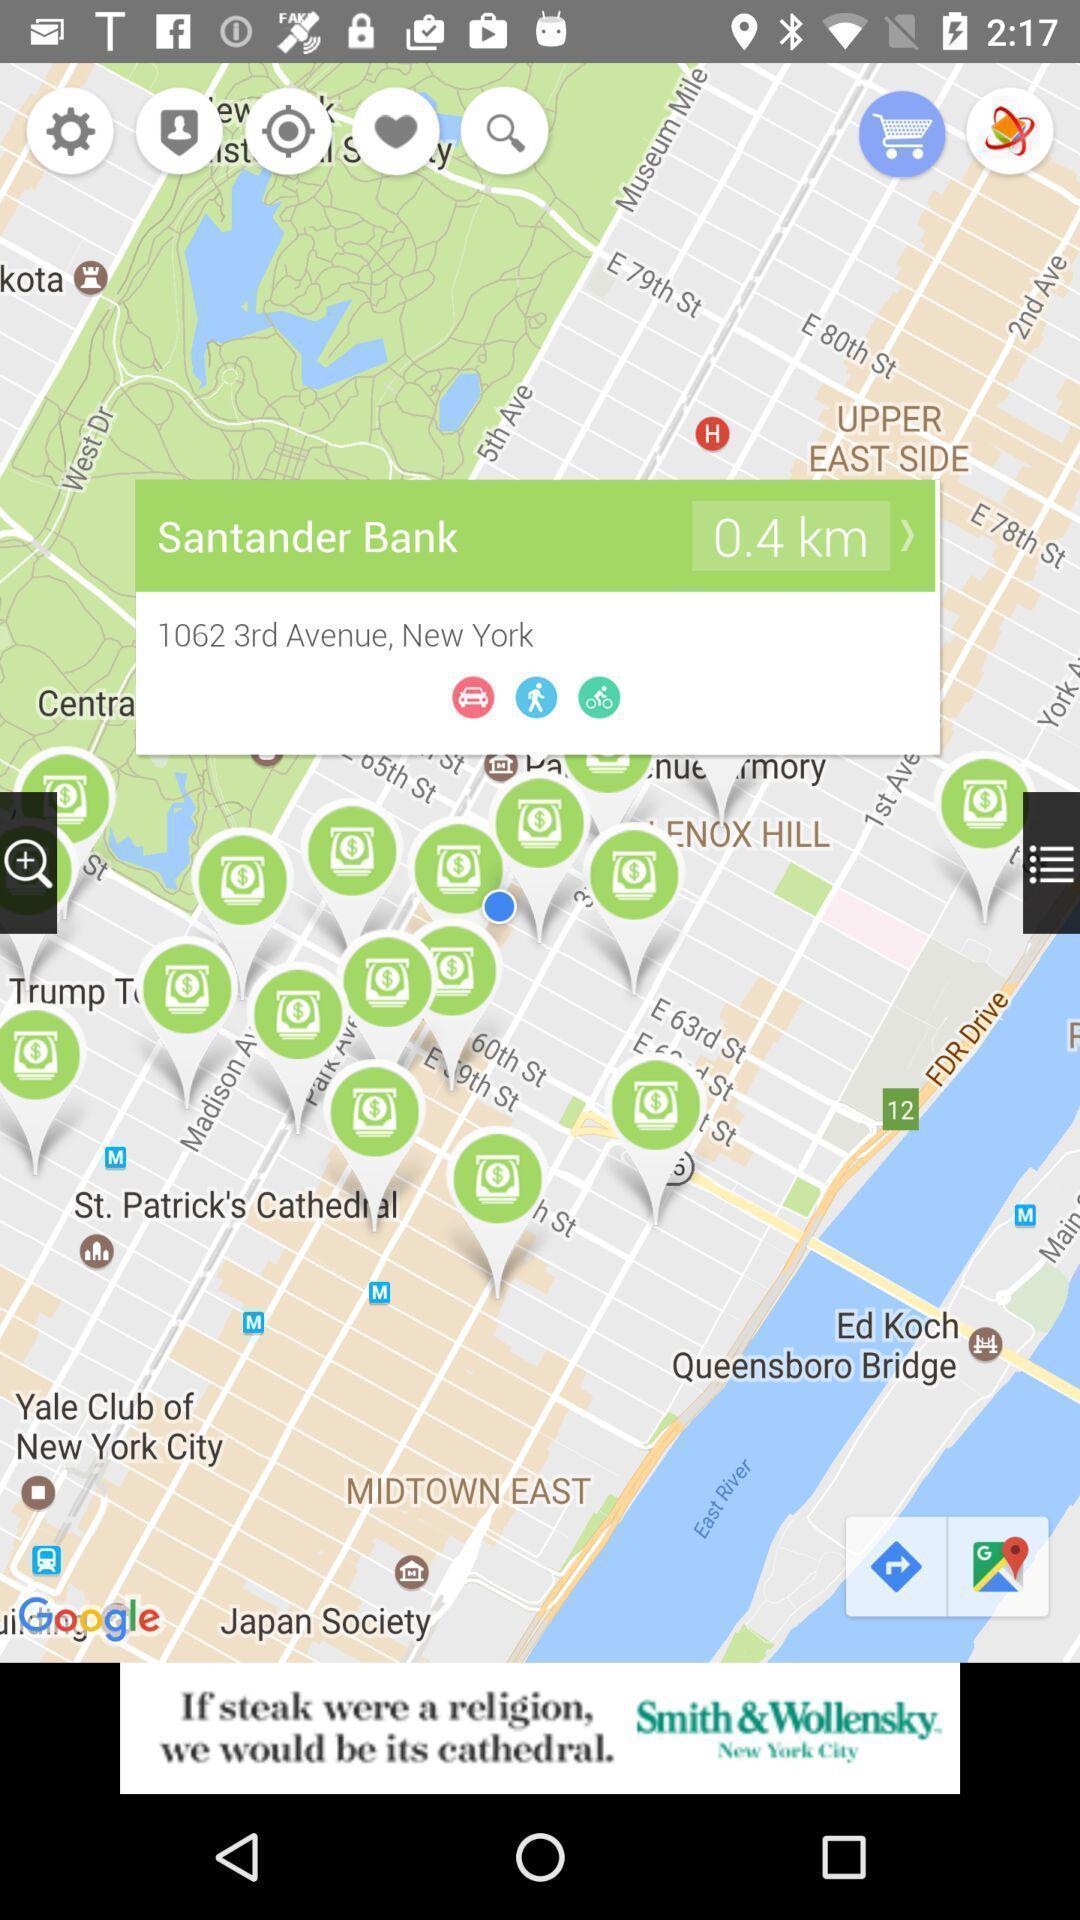Explain the elements present in this screenshot. Screen showing the location of a bank. 